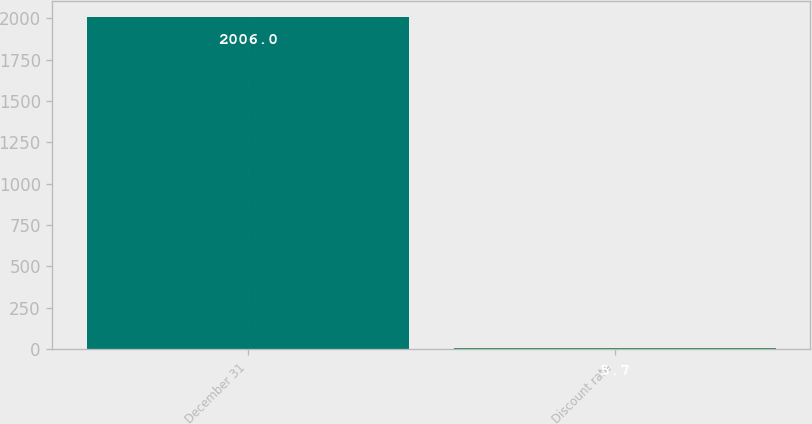Convert chart to OTSL. <chart><loc_0><loc_0><loc_500><loc_500><bar_chart><fcel>December 31<fcel>Discount rate<nl><fcel>2006<fcel>5.7<nl></chart> 